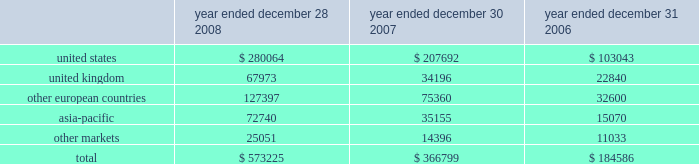Executive deferred compensation plan for the company 2019s executives and members of the board of directors , the company adopted the illumina , inc .
Deferred compensation plan ( the plan ) that became effective january 1 , 2008 .
Eligible participants can contribute up to 80% ( 80 % ) of their base salary and 100% ( 100 % ) of all other forms of compensation into the plan , including bonus , commission and director fees .
The company has agreed to credit the participants 2019 contributions with earnings that reflect the performance of certain independent investment funds .
On a discretionary basis , the company may also make employer contributions to participant accounts in any amount determined by the company .
The vesting schedules of employer contributions are at the sole discretion of the compensation committee .
However , all employer contributions shall become 100% ( 100 % ) vested upon the occurrence of the participant 2019s disability , death or retirement or a change in control of the company .
The benefits under this plan are unsecured .
Participants are generally eligible to receive payment of their vested benefit at the end of their elected deferral period or after termination of their employment with the company for any reason or at a later date to comply with the restrictions of section 409a .
As of december 28 , 2008 , no employer contributions were made to the plan .
In january 2008 , the company also established a rabbi trust for the benefit of its directors and executives under the plan .
In accordance with fasb interpretation ( fin ) no .
46 , consolidation of variable interest entities , an interpretation of arb no .
51 , and eitf 97-14 , accounting for deferred compensation arrangements where amounts earned are held in a rabbi trust and invested , the company has included the assets of the rabbi trust in its consolidated balance sheet since the trust 2019s inception .
As of december 28 , 2008 , the assets of the trust and liabilities of the company were $ 1.3 million .
The assets and liabilities are classified as other assets and accrued liabilities , respectively , on the company 2019s balance sheet as of december 28 , 2008 .
Changes in the values of the assets held by the rabbi trust accrue to the company .
14 .
Segment information , geographic data and significant customers during the first quarter of 2008 , the company reorganized its operating structure into a newly created life sciences business unit , which includes all products and services related to the research market , namely the beadarray , beadxpress and sequencing product lines .
The company also created a diagnostics business unit to focus on the emerging opportunity in molecular diagnostics .
For the year ended december 28 , 2008 , the company had limited activity related to the diagnostics business unit , and operating results were reported on an aggregate basis to the chief operating decision maker of the company , the chief executive officer .
In accordance with sfas no .
131 , disclosures about segments of an enterprise and related information , the company operated in one reportable segment for the year ended december 28 , 2008 .
The company had revenue in the following regions for the years ended december 28 , 2008 , december 30 , 2007 and december 31 , 2006 ( in thousands ) : year ended december 28 , year ended december 30 , year ended december 31 .
Net revenues are attributable to geographic areas based on the region of destination .
Illumina , inc .
Notes to consolidated financial statements 2014 ( continued ) .
What percentage of total revenue in 2008 came from the united kingdom region? 
Computations: (67973 / 573225)
Answer: 0.11858. 